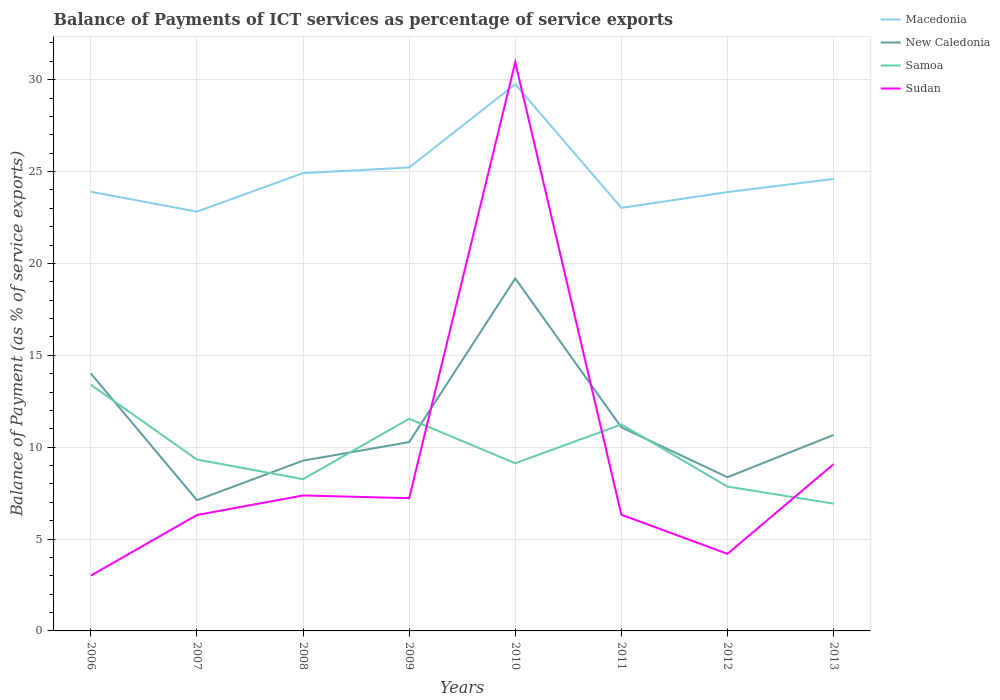How many different coloured lines are there?
Provide a succinct answer. 4. Does the line corresponding to Macedonia intersect with the line corresponding to Samoa?
Give a very brief answer. No. Is the number of lines equal to the number of legend labels?
Provide a succinct answer. Yes. Across all years, what is the maximum balance of payments of ICT services in Samoa?
Your response must be concise. 6.93. What is the total balance of payments of ICT services in Macedonia in the graph?
Your answer should be very brief. 0.62. What is the difference between the highest and the second highest balance of payments of ICT services in Sudan?
Your response must be concise. 27.94. What is the difference between the highest and the lowest balance of payments of ICT services in Macedonia?
Offer a very short reply. 3. Is the balance of payments of ICT services in Samoa strictly greater than the balance of payments of ICT services in New Caledonia over the years?
Make the answer very short. No. How many lines are there?
Provide a short and direct response. 4. How many years are there in the graph?
Offer a very short reply. 8. Where does the legend appear in the graph?
Give a very brief answer. Top right. What is the title of the graph?
Your response must be concise. Balance of Payments of ICT services as percentage of service exports. Does "Antigua and Barbuda" appear as one of the legend labels in the graph?
Offer a terse response. No. What is the label or title of the X-axis?
Ensure brevity in your answer.  Years. What is the label or title of the Y-axis?
Offer a very short reply. Balance of Payment (as % of service exports). What is the Balance of Payment (as % of service exports) of Macedonia in 2006?
Keep it short and to the point. 23.91. What is the Balance of Payment (as % of service exports) of New Caledonia in 2006?
Provide a succinct answer. 14.01. What is the Balance of Payment (as % of service exports) in Samoa in 2006?
Keep it short and to the point. 13.4. What is the Balance of Payment (as % of service exports) of Sudan in 2006?
Keep it short and to the point. 3.01. What is the Balance of Payment (as % of service exports) in Macedonia in 2007?
Provide a succinct answer. 22.82. What is the Balance of Payment (as % of service exports) in New Caledonia in 2007?
Keep it short and to the point. 7.12. What is the Balance of Payment (as % of service exports) of Samoa in 2007?
Keep it short and to the point. 9.33. What is the Balance of Payment (as % of service exports) of Sudan in 2007?
Give a very brief answer. 6.31. What is the Balance of Payment (as % of service exports) of Macedonia in 2008?
Give a very brief answer. 24.92. What is the Balance of Payment (as % of service exports) in New Caledonia in 2008?
Provide a short and direct response. 9.27. What is the Balance of Payment (as % of service exports) in Samoa in 2008?
Your answer should be very brief. 8.26. What is the Balance of Payment (as % of service exports) in Sudan in 2008?
Offer a terse response. 7.37. What is the Balance of Payment (as % of service exports) of Macedonia in 2009?
Provide a short and direct response. 25.22. What is the Balance of Payment (as % of service exports) of New Caledonia in 2009?
Your answer should be compact. 10.28. What is the Balance of Payment (as % of service exports) of Samoa in 2009?
Give a very brief answer. 11.55. What is the Balance of Payment (as % of service exports) in Sudan in 2009?
Give a very brief answer. 7.22. What is the Balance of Payment (as % of service exports) of Macedonia in 2010?
Provide a short and direct response. 29.76. What is the Balance of Payment (as % of service exports) of New Caledonia in 2010?
Provide a succinct answer. 19.18. What is the Balance of Payment (as % of service exports) in Samoa in 2010?
Ensure brevity in your answer.  9.13. What is the Balance of Payment (as % of service exports) in Sudan in 2010?
Offer a terse response. 30.95. What is the Balance of Payment (as % of service exports) in Macedonia in 2011?
Make the answer very short. 23.03. What is the Balance of Payment (as % of service exports) of New Caledonia in 2011?
Offer a very short reply. 11.08. What is the Balance of Payment (as % of service exports) in Samoa in 2011?
Offer a terse response. 11.24. What is the Balance of Payment (as % of service exports) of Sudan in 2011?
Make the answer very short. 6.32. What is the Balance of Payment (as % of service exports) of Macedonia in 2012?
Provide a short and direct response. 23.89. What is the Balance of Payment (as % of service exports) in New Caledonia in 2012?
Provide a succinct answer. 8.37. What is the Balance of Payment (as % of service exports) in Samoa in 2012?
Ensure brevity in your answer.  7.86. What is the Balance of Payment (as % of service exports) in Sudan in 2012?
Your answer should be compact. 4.2. What is the Balance of Payment (as % of service exports) in Macedonia in 2013?
Your answer should be compact. 24.6. What is the Balance of Payment (as % of service exports) of New Caledonia in 2013?
Offer a terse response. 10.66. What is the Balance of Payment (as % of service exports) of Samoa in 2013?
Make the answer very short. 6.93. What is the Balance of Payment (as % of service exports) of Sudan in 2013?
Your answer should be compact. 9.08. Across all years, what is the maximum Balance of Payment (as % of service exports) in Macedonia?
Offer a terse response. 29.76. Across all years, what is the maximum Balance of Payment (as % of service exports) in New Caledonia?
Keep it short and to the point. 19.18. Across all years, what is the maximum Balance of Payment (as % of service exports) in Samoa?
Ensure brevity in your answer.  13.4. Across all years, what is the maximum Balance of Payment (as % of service exports) of Sudan?
Offer a very short reply. 30.95. Across all years, what is the minimum Balance of Payment (as % of service exports) in Macedonia?
Provide a succinct answer. 22.82. Across all years, what is the minimum Balance of Payment (as % of service exports) of New Caledonia?
Your answer should be very brief. 7.12. Across all years, what is the minimum Balance of Payment (as % of service exports) in Samoa?
Your answer should be very brief. 6.93. Across all years, what is the minimum Balance of Payment (as % of service exports) of Sudan?
Ensure brevity in your answer.  3.01. What is the total Balance of Payment (as % of service exports) in Macedonia in the graph?
Provide a short and direct response. 198.14. What is the total Balance of Payment (as % of service exports) of New Caledonia in the graph?
Keep it short and to the point. 89.97. What is the total Balance of Payment (as % of service exports) of Samoa in the graph?
Your answer should be very brief. 77.68. What is the total Balance of Payment (as % of service exports) in Sudan in the graph?
Ensure brevity in your answer.  74.47. What is the difference between the Balance of Payment (as % of service exports) in Macedonia in 2006 and that in 2007?
Provide a short and direct response. 1.08. What is the difference between the Balance of Payment (as % of service exports) of New Caledonia in 2006 and that in 2007?
Provide a succinct answer. 6.89. What is the difference between the Balance of Payment (as % of service exports) in Samoa in 2006 and that in 2007?
Your response must be concise. 4.07. What is the difference between the Balance of Payment (as % of service exports) in Sudan in 2006 and that in 2007?
Keep it short and to the point. -3.3. What is the difference between the Balance of Payment (as % of service exports) of Macedonia in 2006 and that in 2008?
Keep it short and to the point. -1.01. What is the difference between the Balance of Payment (as % of service exports) of New Caledonia in 2006 and that in 2008?
Give a very brief answer. 4.74. What is the difference between the Balance of Payment (as % of service exports) of Samoa in 2006 and that in 2008?
Offer a terse response. 5.14. What is the difference between the Balance of Payment (as % of service exports) of Sudan in 2006 and that in 2008?
Provide a succinct answer. -4.36. What is the difference between the Balance of Payment (as % of service exports) in Macedonia in 2006 and that in 2009?
Offer a terse response. -1.32. What is the difference between the Balance of Payment (as % of service exports) in New Caledonia in 2006 and that in 2009?
Keep it short and to the point. 3.73. What is the difference between the Balance of Payment (as % of service exports) of Samoa in 2006 and that in 2009?
Your answer should be very brief. 1.85. What is the difference between the Balance of Payment (as % of service exports) in Sudan in 2006 and that in 2009?
Make the answer very short. -4.21. What is the difference between the Balance of Payment (as % of service exports) in Macedonia in 2006 and that in 2010?
Provide a short and direct response. -5.85. What is the difference between the Balance of Payment (as % of service exports) of New Caledonia in 2006 and that in 2010?
Give a very brief answer. -5.17. What is the difference between the Balance of Payment (as % of service exports) of Samoa in 2006 and that in 2010?
Offer a terse response. 4.27. What is the difference between the Balance of Payment (as % of service exports) of Sudan in 2006 and that in 2010?
Offer a terse response. -27.94. What is the difference between the Balance of Payment (as % of service exports) in Macedonia in 2006 and that in 2011?
Ensure brevity in your answer.  0.88. What is the difference between the Balance of Payment (as % of service exports) of New Caledonia in 2006 and that in 2011?
Give a very brief answer. 2.93. What is the difference between the Balance of Payment (as % of service exports) in Samoa in 2006 and that in 2011?
Keep it short and to the point. 2.16. What is the difference between the Balance of Payment (as % of service exports) of Sudan in 2006 and that in 2011?
Ensure brevity in your answer.  -3.31. What is the difference between the Balance of Payment (as % of service exports) in Macedonia in 2006 and that in 2012?
Your answer should be very brief. 0.02. What is the difference between the Balance of Payment (as % of service exports) in New Caledonia in 2006 and that in 2012?
Keep it short and to the point. 5.65. What is the difference between the Balance of Payment (as % of service exports) of Samoa in 2006 and that in 2012?
Provide a succinct answer. 5.54. What is the difference between the Balance of Payment (as % of service exports) in Sudan in 2006 and that in 2012?
Give a very brief answer. -1.19. What is the difference between the Balance of Payment (as % of service exports) of Macedonia in 2006 and that in 2013?
Your answer should be compact. -0.7. What is the difference between the Balance of Payment (as % of service exports) in New Caledonia in 2006 and that in 2013?
Keep it short and to the point. 3.35. What is the difference between the Balance of Payment (as % of service exports) of Samoa in 2006 and that in 2013?
Offer a terse response. 6.47. What is the difference between the Balance of Payment (as % of service exports) in Sudan in 2006 and that in 2013?
Your response must be concise. -6.07. What is the difference between the Balance of Payment (as % of service exports) in Macedonia in 2007 and that in 2008?
Ensure brevity in your answer.  -2.1. What is the difference between the Balance of Payment (as % of service exports) in New Caledonia in 2007 and that in 2008?
Provide a short and direct response. -2.15. What is the difference between the Balance of Payment (as % of service exports) in Samoa in 2007 and that in 2008?
Your answer should be compact. 1.07. What is the difference between the Balance of Payment (as % of service exports) of Sudan in 2007 and that in 2008?
Make the answer very short. -1.06. What is the difference between the Balance of Payment (as % of service exports) of Macedonia in 2007 and that in 2009?
Your answer should be very brief. -2.4. What is the difference between the Balance of Payment (as % of service exports) in New Caledonia in 2007 and that in 2009?
Make the answer very short. -3.16. What is the difference between the Balance of Payment (as % of service exports) in Samoa in 2007 and that in 2009?
Make the answer very short. -2.22. What is the difference between the Balance of Payment (as % of service exports) in Sudan in 2007 and that in 2009?
Ensure brevity in your answer.  -0.92. What is the difference between the Balance of Payment (as % of service exports) in Macedonia in 2007 and that in 2010?
Offer a terse response. -6.93. What is the difference between the Balance of Payment (as % of service exports) in New Caledonia in 2007 and that in 2010?
Keep it short and to the point. -12.07. What is the difference between the Balance of Payment (as % of service exports) of Samoa in 2007 and that in 2010?
Keep it short and to the point. 0.2. What is the difference between the Balance of Payment (as % of service exports) in Sudan in 2007 and that in 2010?
Ensure brevity in your answer.  -24.64. What is the difference between the Balance of Payment (as % of service exports) of Macedonia in 2007 and that in 2011?
Your response must be concise. -0.21. What is the difference between the Balance of Payment (as % of service exports) of New Caledonia in 2007 and that in 2011?
Your answer should be very brief. -3.97. What is the difference between the Balance of Payment (as % of service exports) of Samoa in 2007 and that in 2011?
Keep it short and to the point. -1.91. What is the difference between the Balance of Payment (as % of service exports) of Sudan in 2007 and that in 2011?
Offer a terse response. -0.01. What is the difference between the Balance of Payment (as % of service exports) in Macedonia in 2007 and that in 2012?
Your response must be concise. -1.06. What is the difference between the Balance of Payment (as % of service exports) of New Caledonia in 2007 and that in 2012?
Your answer should be compact. -1.25. What is the difference between the Balance of Payment (as % of service exports) in Samoa in 2007 and that in 2012?
Ensure brevity in your answer.  1.47. What is the difference between the Balance of Payment (as % of service exports) of Sudan in 2007 and that in 2012?
Offer a very short reply. 2.11. What is the difference between the Balance of Payment (as % of service exports) of Macedonia in 2007 and that in 2013?
Ensure brevity in your answer.  -1.78. What is the difference between the Balance of Payment (as % of service exports) of New Caledonia in 2007 and that in 2013?
Provide a succinct answer. -3.55. What is the difference between the Balance of Payment (as % of service exports) in Samoa in 2007 and that in 2013?
Your answer should be compact. 2.4. What is the difference between the Balance of Payment (as % of service exports) in Sudan in 2007 and that in 2013?
Make the answer very short. -2.77. What is the difference between the Balance of Payment (as % of service exports) in Macedonia in 2008 and that in 2009?
Ensure brevity in your answer.  -0.31. What is the difference between the Balance of Payment (as % of service exports) of New Caledonia in 2008 and that in 2009?
Offer a very short reply. -1.01. What is the difference between the Balance of Payment (as % of service exports) in Samoa in 2008 and that in 2009?
Ensure brevity in your answer.  -3.29. What is the difference between the Balance of Payment (as % of service exports) in Sudan in 2008 and that in 2009?
Provide a succinct answer. 0.15. What is the difference between the Balance of Payment (as % of service exports) of Macedonia in 2008 and that in 2010?
Offer a very short reply. -4.84. What is the difference between the Balance of Payment (as % of service exports) in New Caledonia in 2008 and that in 2010?
Your response must be concise. -9.92. What is the difference between the Balance of Payment (as % of service exports) of Samoa in 2008 and that in 2010?
Keep it short and to the point. -0.87. What is the difference between the Balance of Payment (as % of service exports) of Sudan in 2008 and that in 2010?
Provide a short and direct response. -23.58. What is the difference between the Balance of Payment (as % of service exports) in Macedonia in 2008 and that in 2011?
Offer a terse response. 1.89. What is the difference between the Balance of Payment (as % of service exports) of New Caledonia in 2008 and that in 2011?
Make the answer very short. -1.81. What is the difference between the Balance of Payment (as % of service exports) in Samoa in 2008 and that in 2011?
Offer a very short reply. -2.98. What is the difference between the Balance of Payment (as % of service exports) of Sudan in 2008 and that in 2011?
Offer a very short reply. 1.05. What is the difference between the Balance of Payment (as % of service exports) of Macedonia in 2008 and that in 2012?
Ensure brevity in your answer.  1.03. What is the difference between the Balance of Payment (as % of service exports) of New Caledonia in 2008 and that in 2012?
Provide a short and direct response. 0.9. What is the difference between the Balance of Payment (as % of service exports) in Samoa in 2008 and that in 2012?
Make the answer very short. 0.4. What is the difference between the Balance of Payment (as % of service exports) in Sudan in 2008 and that in 2012?
Your answer should be compact. 3.18. What is the difference between the Balance of Payment (as % of service exports) in Macedonia in 2008 and that in 2013?
Your answer should be compact. 0.32. What is the difference between the Balance of Payment (as % of service exports) in New Caledonia in 2008 and that in 2013?
Offer a terse response. -1.4. What is the difference between the Balance of Payment (as % of service exports) in Samoa in 2008 and that in 2013?
Give a very brief answer. 1.33. What is the difference between the Balance of Payment (as % of service exports) of Sudan in 2008 and that in 2013?
Provide a succinct answer. -1.71. What is the difference between the Balance of Payment (as % of service exports) in Macedonia in 2009 and that in 2010?
Provide a succinct answer. -4.53. What is the difference between the Balance of Payment (as % of service exports) in New Caledonia in 2009 and that in 2010?
Ensure brevity in your answer.  -8.91. What is the difference between the Balance of Payment (as % of service exports) in Samoa in 2009 and that in 2010?
Your answer should be compact. 2.42. What is the difference between the Balance of Payment (as % of service exports) of Sudan in 2009 and that in 2010?
Keep it short and to the point. -23.73. What is the difference between the Balance of Payment (as % of service exports) in Macedonia in 2009 and that in 2011?
Your response must be concise. 2.2. What is the difference between the Balance of Payment (as % of service exports) of New Caledonia in 2009 and that in 2011?
Keep it short and to the point. -0.8. What is the difference between the Balance of Payment (as % of service exports) in Samoa in 2009 and that in 2011?
Provide a succinct answer. 0.31. What is the difference between the Balance of Payment (as % of service exports) in Sudan in 2009 and that in 2011?
Provide a succinct answer. 0.9. What is the difference between the Balance of Payment (as % of service exports) in Macedonia in 2009 and that in 2012?
Keep it short and to the point. 1.34. What is the difference between the Balance of Payment (as % of service exports) in New Caledonia in 2009 and that in 2012?
Your answer should be compact. 1.91. What is the difference between the Balance of Payment (as % of service exports) in Samoa in 2009 and that in 2012?
Make the answer very short. 3.69. What is the difference between the Balance of Payment (as % of service exports) of Sudan in 2009 and that in 2012?
Your answer should be compact. 3.03. What is the difference between the Balance of Payment (as % of service exports) in Macedonia in 2009 and that in 2013?
Your answer should be compact. 0.62. What is the difference between the Balance of Payment (as % of service exports) of New Caledonia in 2009 and that in 2013?
Offer a very short reply. -0.39. What is the difference between the Balance of Payment (as % of service exports) in Samoa in 2009 and that in 2013?
Provide a short and direct response. 4.62. What is the difference between the Balance of Payment (as % of service exports) in Sudan in 2009 and that in 2013?
Keep it short and to the point. -1.86. What is the difference between the Balance of Payment (as % of service exports) of Macedonia in 2010 and that in 2011?
Your response must be concise. 6.73. What is the difference between the Balance of Payment (as % of service exports) of New Caledonia in 2010 and that in 2011?
Your answer should be very brief. 8.1. What is the difference between the Balance of Payment (as % of service exports) of Samoa in 2010 and that in 2011?
Keep it short and to the point. -2.11. What is the difference between the Balance of Payment (as % of service exports) in Sudan in 2010 and that in 2011?
Ensure brevity in your answer.  24.63. What is the difference between the Balance of Payment (as % of service exports) of Macedonia in 2010 and that in 2012?
Your answer should be very brief. 5.87. What is the difference between the Balance of Payment (as % of service exports) in New Caledonia in 2010 and that in 2012?
Give a very brief answer. 10.82. What is the difference between the Balance of Payment (as % of service exports) in Samoa in 2010 and that in 2012?
Keep it short and to the point. 1.27. What is the difference between the Balance of Payment (as % of service exports) in Sudan in 2010 and that in 2012?
Make the answer very short. 26.76. What is the difference between the Balance of Payment (as % of service exports) of Macedonia in 2010 and that in 2013?
Provide a succinct answer. 5.15. What is the difference between the Balance of Payment (as % of service exports) in New Caledonia in 2010 and that in 2013?
Provide a short and direct response. 8.52. What is the difference between the Balance of Payment (as % of service exports) of Samoa in 2010 and that in 2013?
Your response must be concise. 2.2. What is the difference between the Balance of Payment (as % of service exports) of Sudan in 2010 and that in 2013?
Your answer should be compact. 21.87. What is the difference between the Balance of Payment (as % of service exports) in Macedonia in 2011 and that in 2012?
Your response must be concise. -0.86. What is the difference between the Balance of Payment (as % of service exports) of New Caledonia in 2011 and that in 2012?
Offer a very short reply. 2.72. What is the difference between the Balance of Payment (as % of service exports) of Samoa in 2011 and that in 2012?
Provide a short and direct response. 3.38. What is the difference between the Balance of Payment (as % of service exports) in Sudan in 2011 and that in 2012?
Keep it short and to the point. 2.13. What is the difference between the Balance of Payment (as % of service exports) of Macedonia in 2011 and that in 2013?
Offer a terse response. -1.57. What is the difference between the Balance of Payment (as % of service exports) of New Caledonia in 2011 and that in 2013?
Provide a succinct answer. 0.42. What is the difference between the Balance of Payment (as % of service exports) of Samoa in 2011 and that in 2013?
Offer a very short reply. 4.31. What is the difference between the Balance of Payment (as % of service exports) of Sudan in 2011 and that in 2013?
Give a very brief answer. -2.76. What is the difference between the Balance of Payment (as % of service exports) of Macedonia in 2012 and that in 2013?
Make the answer very short. -0.72. What is the difference between the Balance of Payment (as % of service exports) in New Caledonia in 2012 and that in 2013?
Provide a short and direct response. -2.3. What is the difference between the Balance of Payment (as % of service exports) in Samoa in 2012 and that in 2013?
Provide a succinct answer. 0.93. What is the difference between the Balance of Payment (as % of service exports) of Sudan in 2012 and that in 2013?
Your response must be concise. -4.88. What is the difference between the Balance of Payment (as % of service exports) of Macedonia in 2006 and the Balance of Payment (as % of service exports) of New Caledonia in 2007?
Ensure brevity in your answer.  16.79. What is the difference between the Balance of Payment (as % of service exports) in Macedonia in 2006 and the Balance of Payment (as % of service exports) in Samoa in 2007?
Provide a succinct answer. 14.58. What is the difference between the Balance of Payment (as % of service exports) of Macedonia in 2006 and the Balance of Payment (as % of service exports) of Sudan in 2007?
Keep it short and to the point. 17.6. What is the difference between the Balance of Payment (as % of service exports) in New Caledonia in 2006 and the Balance of Payment (as % of service exports) in Samoa in 2007?
Your response must be concise. 4.68. What is the difference between the Balance of Payment (as % of service exports) in New Caledonia in 2006 and the Balance of Payment (as % of service exports) in Sudan in 2007?
Your answer should be compact. 7.7. What is the difference between the Balance of Payment (as % of service exports) of Samoa in 2006 and the Balance of Payment (as % of service exports) of Sudan in 2007?
Provide a succinct answer. 7.09. What is the difference between the Balance of Payment (as % of service exports) of Macedonia in 2006 and the Balance of Payment (as % of service exports) of New Caledonia in 2008?
Offer a very short reply. 14.64. What is the difference between the Balance of Payment (as % of service exports) of Macedonia in 2006 and the Balance of Payment (as % of service exports) of Samoa in 2008?
Provide a short and direct response. 15.65. What is the difference between the Balance of Payment (as % of service exports) of Macedonia in 2006 and the Balance of Payment (as % of service exports) of Sudan in 2008?
Keep it short and to the point. 16.53. What is the difference between the Balance of Payment (as % of service exports) in New Caledonia in 2006 and the Balance of Payment (as % of service exports) in Samoa in 2008?
Ensure brevity in your answer.  5.75. What is the difference between the Balance of Payment (as % of service exports) of New Caledonia in 2006 and the Balance of Payment (as % of service exports) of Sudan in 2008?
Your response must be concise. 6.64. What is the difference between the Balance of Payment (as % of service exports) in Samoa in 2006 and the Balance of Payment (as % of service exports) in Sudan in 2008?
Give a very brief answer. 6.03. What is the difference between the Balance of Payment (as % of service exports) in Macedonia in 2006 and the Balance of Payment (as % of service exports) in New Caledonia in 2009?
Provide a short and direct response. 13.63. What is the difference between the Balance of Payment (as % of service exports) of Macedonia in 2006 and the Balance of Payment (as % of service exports) of Samoa in 2009?
Provide a short and direct response. 12.36. What is the difference between the Balance of Payment (as % of service exports) in Macedonia in 2006 and the Balance of Payment (as % of service exports) in Sudan in 2009?
Your answer should be very brief. 16.68. What is the difference between the Balance of Payment (as % of service exports) of New Caledonia in 2006 and the Balance of Payment (as % of service exports) of Samoa in 2009?
Your response must be concise. 2.47. What is the difference between the Balance of Payment (as % of service exports) of New Caledonia in 2006 and the Balance of Payment (as % of service exports) of Sudan in 2009?
Your answer should be compact. 6.79. What is the difference between the Balance of Payment (as % of service exports) of Samoa in 2006 and the Balance of Payment (as % of service exports) of Sudan in 2009?
Your answer should be compact. 6.17. What is the difference between the Balance of Payment (as % of service exports) of Macedonia in 2006 and the Balance of Payment (as % of service exports) of New Caledonia in 2010?
Give a very brief answer. 4.72. What is the difference between the Balance of Payment (as % of service exports) of Macedonia in 2006 and the Balance of Payment (as % of service exports) of Samoa in 2010?
Provide a short and direct response. 14.78. What is the difference between the Balance of Payment (as % of service exports) in Macedonia in 2006 and the Balance of Payment (as % of service exports) in Sudan in 2010?
Your answer should be compact. -7.05. What is the difference between the Balance of Payment (as % of service exports) in New Caledonia in 2006 and the Balance of Payment (as % of service exports) in Samoa in 2010?
Provide a succinct answer. 4.89. What is the difference between the Balance of Payment (as % of service exports) in New Caledonia in 2006 and the Balance of Payment (as % of service exports) in Sudan in 2010?
Your answer should be compact. -16.94. What is the difference between the Balance of Payment (as % of service exports) of Samoa in 2006 and the Balance of Payment (as % of service exports) of Sudan in 2010?
Your answer should be compact. -17.55. What is the difference between the Balance of Payment (as % of service exports) of Macedonia in 2006 and the Balance of Payment (as % of service exports) of New Caledonia in 2011?
Keep it short and to the point. 12.82. What is the difference between the Balance of Payment (as % of service exports) of Macedonia in 2006 and the Balance of Payment (as % of service exports) of Samoa in 2011?
Keep it short and to the point. 12.67. What is the difference between the Balance of Payment (as % of service exports) in Macedonia in 2006 and the Balance of Payment (as % of service exports) in Sudan in 2011?
Provide a short and direct response. 17.58. What is the difference between the Balance of Payment (as % of service exports) in New Caledonia in 2006 and the Balance of Payment (as % of service exports) in Samoa in 2011?
Keep it short and to the point. 2.77. What is the difference between the Balance of Payment (as % of service exports) in New Caledonia in 2006 and the Balance of Payment (as % of service exports) in Sudan in 2011?
Ensure brevity in your answer.  7.69. What is the difference between the Balance of Payment (as % of service exports) in Samoa in 2006 and the Balance of Payment (as % of service exports) in Sudan in 2011?
Give a very brief answer. 7.07. What is the difference between the Balance of Payment (as % of service exports) in Macedonia in 2006 and the Balance of Payment (as % of service exports) in New Caledonia in 2012?
Keep it short and to the point. 15.54. What is the difference between the Balance of Payment (as % of service exports) in Macedonia in 2006 and the Balance of Payment (as % of service exports) in Samoa in 2012?
Provide a short and direct response. 16.05. What is the difference between the Balance of Payment (as % of service exports) of Macedonia in 2006 and the Balance of Payment (as % of service exports) of Sudan in 2012?
Ensure brevity in your answer.  19.71. What is the difference between the Balance of Payment (as % of service exports) in New Caledonia in 2006 and the Balance of Payment (as % of service exports) in Samoa in 2012?
Your answer should be very brief. 6.16. What is the difference between the Balance of Payment (as % of service exports) of New Caledonia in 2006 and the Balance of Payment (as % of service exports) of Sudan in 2012?
Give a very brief answer. 9.82. What is the difference between the Balance of Payment (as % of service exports) of Samoa in 2006 and the Balance of Payment (as % of service exports) of Sudan in 2012?
Make the answer very short. 9.2. What is the difference between the Balance of Payment (as % of service exports) in Macedonia in 2006 and the Balance of Payment (as % of service exports) in New Caledonia in 2013?
Your answer should be compact. 13.24. What is the difference between the Balance of Payment (as % of service exports) of Macedonia in 2006 and the Balance of Payment (as % of service exports) of Samoa in 2013?
Your answer should be compact. 16.98. What is the difference between the Balance of Payment (as % of service exports) in Macedonia in 2006 and the Balance of Payment (as % of service exports) in Sudan in 2013?
Ensure brevity in your answer.  14.83. What is the difference between the Balance of Payment (as % of service exports) in New Caledonia in 2006 and the Balance of Payment (as % of service exports) in Samoa in 2013?
Provide a short and direct response. 7.08. What is the difference between the Balance of Payment (as % of service exports) of New Caledonia in 2006 and the Balance of Payment (as % of service exports) of Sudan in 2013?
Offer a very short reply. 4.93. What is the difference between the Balance of Payment (as % of service exports) of Samoa in 2006 and the Balance of Payment (as % of service exports) of Sudan in 2013?
Offer a very short reply. 4.32. What is the difference between the Balance of Payment (as % of service exports) of Macedonia in 2007 and the Balance of Payment (as % of service exports) of New Caledonia in 2008?
Offer a very short reply. 13.55. What is the difference between the Balance of Payment (as % of service exports) in Macedonia in 2007 and the Balance of Payment (as % of service exports) in Samoa in 2008?
Keep it short and to the point. 14.56. What is the difference between the Balance of Payment (as % of service exports) in Macedonia in 2007 and the Balance of Payment (as % of service exports) in Sudan in 2008?
Ensure brevity in your answer.  15.45. What is the difference between the Balance of Payment (as % of service exports) of New Caledonia in 2007 and the Balance of Payment (as % of service exports) of Samoa in 2008?
Your answer should be compact. -1.14. What is the difference between the Balance of Payment (as % of service exports) of New Caledonia in 2007 and the Balance of Payment (as % of service exports) of Sudan in 2008?
Provide a succinct answer. -0.26. What is the difference between the Balance of Payment (as % of service exports) in Samoa in 2007 and the Balance of Payment (as % of service exports) in Sudan in 2008?
Give a very brief answer. 1.95. What is the difference between the Balance of Payment (as % of service exports) of Macedonia in 2007 and the Balance of Payment (as % of service exports) of New Caledonia in 2009?
Give a very brief answer. 12.54. What is the difference between the Balance of Payment (as % of service exports) in Macedonia in 2007 and the Balance of Payment (as % of service exports) in Samoa in 2009?
Your answer should be very brief. 11.27. What is the difference between the Balance of Payment (as % of service exports) in Macedonia in 2007 and the Balance of Payment (as % of service exports) in Sudan in 2009?
Your answer should be very brief. 15.6. What is the difference between the Balance of Payment (as % of service exports) of New Caledonia in 2007 and the Balance of Payment (as % of service exports) of Samoa in 2009?
Offer a very short reply. -4.43. What is the difference between the Balance of Payment (as % of service exports) in New Caledonia in 2007 and the Balance of Payment (as % of service exports) in Sudan in 2009?
Ensure brevity in your answer.  -0.11. What is the difference between the Balance of Payment (as % of service exports) in Samoa in 2007 and the Balance of Payment (as % of service exports) in Sudan in 2009?
Provide a short and direct response. 2.1. What is the difference between the Balance of Payment (as % of service exports) in Macedonia in 2007 and the Balance of Payment (as % of service exports) in New Caledonia in 2010?
Provide a succinct answer. 3.64. What is the difference between the Balance of Payment (as % of service exports) in Macedonia in 2007 and the Balance of Payment (as % of service exports) in Samoa in 2010?
Keep it short and to the point. 13.7. What is the difference between the Balance of Payment (as % of service exports) in Macedonia in 2007 and the Balance of Payment (as % of service exports) in Sudan in 2010?
Your answer should be very brief. -8.13. What is the difference between the Balance of Payment (as % of service exports) of New Caledonia in 2007 and the Balance of Payment (as % of service exports) of Samoa in 2010?
Your answer should be very brief. -2.01. What is the difference between the Balance of Payment (as % of service exports) of New Caledonia in 2007 and the Balance of Payment (as % of service exports) of Sudan in 2010?
Provide a short and direct response. -23.84. What is the difference between the Balance of Payment (as % of service exports) in Samoa in 2007 and the Balance of Payment (as % of service exports) in Sudan in 2010?
Provide a succinct answer. -21.62. What is the difference between the Balance of Payment (as % of service exports) in Macedonia in 2007 and the Balance of Payment (as % of service exports) in New Caledonia in 2011?
Give a very brief answer. 11.74. What is the difference between the Balance of Payment (as % of service exports) of Macedonia in 2007 and the Balance of Payment (as % of service exports) of Samoa in 2011?
Your answer should be very brief. 11.58. What is the difference between the Balance of Payment (as % of service exports) of Macedonia in 2007 and the Balance of Payment (as % of service exports) of Sudan in 2011?
Your response must be concise. 16.5. What is the difference between the Balance of Payment (as % of service exports) in New Caledonia in 2007 and the Balance of Payment (as % of service exports) in Samoa in 2011?
Give a very brief answer. -4.12. What is the difference between the Balance of Payment (as % of service exports) of New Caledonia in 2007 and the Balance of Payment (as % of service exports) of Sudan in 2011?
Keep it short and to the point. 0.79. What is the difference between the Balance of Payment (as % of service exports) in Samoa in 2007 and the Balance of Payment (as % of service exports) in Sudan in 2011?
Provide a short and direct response. 3. What is the difference between the Balance of Payment (as % of service exports) of Macedonia in 2007 and the Balance of Payment (as % of service exports) of New Caledonia in 2012?
Your answer should be compact. 14.45. What is the difference between the Balance of Payment (as % of service exports) in Macedonia in 2007 and the Balance of Payment (as % of service exports) in Samoa in 2012?
Ensure brevity in your answer.  14.97. What is the difference between the Balance of Payment (as % of service exports) in Macedonia in 2007 and the Balance of Payment (as % of service exports) in Sudan in 2012?
Give a very brief answer. 18.63. What is the difference between the Balance of Payment (as % of service exports) in New Caledonia in 2007 and the Balance of Payment (as % of service exports) in Samoa in 2012?
Offer a very short reply. -0.74. What is the difference between the Balance of Payment (as % of service exports) of New Caledonia in 2007 and the Balance of Payment (as % of service exports) of Sudan in 2012?
Keep it short and to the point. 2.92. What is the difference between the Balance of Payment (as % of service exports) in Samoa in 2007 and the Balance of Payment (as % of service exports) in Sudan in 2012?
Offer a very short reply. 5.13. What is the difference between the Balance of Payment (as % of service exports) in Macedonia in 2007 and the Balance of Payment (as % of service exports) in New Caledonia in 2013?
Your answer should be very brief. 12.16. What is the difference between the Balance of Payment (as % of service exports) of Macedonia in 2007 and the Balance of Payment (as % of service exports) of Samoa in 2013?
Your answer should be very brief. 15.89. What is the difference between the Balance of Payment (as % of service exports) of Macedonia in 2007 and the Balance of Payment (as % of service exports) of Sudan in 2013?
Make the answer very short. 13.74. What is the difference between the Balance of Payment (as % of service exports) in New Caledonia in 2007 and the Balance of Payment (as % of service exports) in Samoa in 2013?
Make the answer very short. 0.19. What is the difference between the Balance of Payment (as % of service exports) of New Caledonia in 2007 and the Balance of Payment (as % of service exports) of Sudan in 2013?
Offer a very short reply. -1.96. What is the difference between the Balance of Payment (as % of service exports) of Samoa in 2007 and the Balance of Payment (as % of service exports) of Sudan in 2013?
Make the answer very short. 0.25. What is the difference between the Balance of Payment (as % of service exports) of Macedonia in 2008 and the Balance of Payment (as % of service exports) of New Caledonia in 2009?
Give a very brief answer. 14.64. What is the difference between the Balance of Payment (as % of service exports) of Macedonia in 2008 and the Balance of Payment (as % of service exports) of Samoa in 2009?
Offer a terse response. 13.37. What is the difference between the Balance of Payment (as % of service exports) in Macedonia in 2008 and the Balance of Payment (as % of service exports) in Sudan in 2009?
Your answer should be compact. 17.69. What is the difference between the Balance of Payment (as % of service exports) of New Caledonia in 2008 and the Balance of Payment (as % of service exports) of Samoa in 2009?
Provide a short and direct response. -2.28. What is the difference between the Balance of Payment (as % of service exports) of New Caledonia in 2008 and the Balance of Payment (as % of service exports) of Sudan in 2009?
Your response must be concise. 2.04. What is the difference between the Balance of Payment (as % of service exports) of Samoa in 2008 and the Balance of Payment (as % of service exports) of Sudan in 2009?
Offer a very short reply. 1.03. What is the difference between the Balance of Payment (as % of service exports) in Macedonia in 2008 and the Balance of Payment (as % of service exports) in New Caledonia in 2010?
Provide a succinct answer. 5.73. What is the difference between the Balance of Payment (as % of service exports) of Macedonia in 2008 and the Balance of Payment (as % of service exports) of Samoa in 2010?
Make the answer very short. 15.79. What is the difference between the Balance of Payment (as % of service exports) of Macedonia in 2008 and the Balance of Payment (as % of service exports) of Sudan in 2010?
Keep it short and to the point. -6.03. What is the difference between the Balance of Payment (as % of service exports) of New Caledonia in 2008 and the Balance of Payment (as % of service exports) of Samoa in 2010?
Your response must be concise. 0.14. What is the difference between the Balance of Payment (as % of service exports) in New Caledonia in 2008 and the Balance of Payment (as % of service exports) in Sudan in 2010?
Make the answer very short. -21.68. What is the difference between the Balance of Payment (as % of service exports) of Samoa in 2008 and the Balance of Payment (as % of service exports) of Sudan in 2010?
Your answer should be very brief. -22.69. What is the difference between the Balance of Payment (as % of service exports) in Macedonia in 2008 and the Balance of Payment (as % of service exports) in New Caledonia in 2011?
Offer a terse response. 13.84. What is the difference between the Balance of Payment (as % of service exports) of Macedonia in 2008 and the Balance of Payment (as % of service exports) of Samoa in 2011?
Your answer should be compact. 13.68. What is the difference between the Balance of Payment (as % of service exports) of Macedonia in 2008 and the Balance of Payment (as % of service exports) of Sudan in 2011?
Provide a succinct answer. 18.59. What is the difference between the Balance of Payment (as % of service exports) in New Caledonia in 2008 and the Balance of Payment (as % of service exports) in Samoa in 2011?
Offer a very short reply. -1.97. What is the difference between the Balance of Payment (as % of service exports) of New Caledonia in 2008 and the Balance of Payment (as % of service exports) of Sudan in 2011?
Your response must be concise. 2.94. What is the difference between the Balance of Payment (as % of service exports) of Samoa in 2008 and the Balance of Payment (as % of service exports) of Sudan in 2011?
Your answer should be compact. 1.94. What is the difference between the Balance of Payment (as % of service exports) of Macedonia in 2008 and the Balance of Payment (as % of service exports) of New Caledonia in 2012?
Ensure brevity in your answer.  16.55. What is the difference between the Balance of Payment (as % of service exports) in Macedonia in 2008 and the Balance of Payment (as % of service exports) in Samoa in 2012?
Keep it short and to the point. 17.06. What is the difference between the Balance of Payment (as % of service exports) in Macedonia in 2008 and the Balance of Payment (as % of service exports) in Sudan in 2012?
Keep it short and to the point. 20.72. What is the difference between the Balance of Payment (as % of service exports) of New Caledonia in 2008 and the Balance of Payment (as % of service exports) of Samoa in 2012?
Offer a terse response. 1.41. What is the difference between the Balance of Payment (as % of service exports) in New Caledonia in 2008 and the Balance of Payment (as % of service exports) in Sudan in 2012?
Give a very brief answer. 5.07. What is the difference between the Balance of Payment (as % of service exports) of Samoa in 2008 and the Balance of Payment (as % of service exports) of Sudan in 2012?
Give a very brief answer. 4.06. What is the difference between the Balance of Payment (as % of service exports) of Macedonia in 2008 and the Balance of Payment (as % of service exports) of New Caledonia in 2013?
Your answer should be compact. 14.25. What is the difference between the Balance of Payment (as % of service exports) of Macedonia in 2008 and the Balance of Payment (as % of service exports) of Samoa in 2013?
Offer a very short reply. 17.99. What is the difference between the Balance of Payment (as % of service exports) in Macedonia in 2008 and the Balance of Payment (as % of service exports) in Sudan in 2013?
Give a very brief answer. 15.84. What is the difference between the Balance of Payment (as % of service exports) of New Caledonia in 2008 and the Balance of Payment (as % of service exports) of Samoa in 2013?
Make the answer very short. 2.34. What is the difference between the Balance of Payment (as % of service exports) in New Caledonia in 2008 and the Balance of Payment (as % of service exports) in Sudan in 2013?
Offer a very short reply. 0.19. What is the difference between the Balance of Payment (as % of service exports) in Samoa in 2008 and the Balance of Payment (as % of service exports) in Sudan in 2013?
Your answer should be very brief. -0.82. What is the difference between the Balance of Payment (as % of service exports) of Macedonia in 2009 and the Balance of Payment (as % of service exports) of New Caledonia in 2010?
Your response must be concise. 6.04. What is the difference between the Balance of Payment (as % of service exports) of Macedonia in 2009 and the Balance of Payment (as % of service exports) of Samoa in 2010?
Offer a very short reply. 16.1. What is the difference between the Balance of Payment (as % of service exports) of Macedonia in 2009 and the Balance of Payment (as % of service exports) of Sudan in 2010?
Ensure brevity in your answer.  -5.73. What is the difference between the Balance of Payment (as % of service exports) of New Caledonia in 2009 and the Balance of Payment (as % of service exports) of Samoa in 2010?
Your answer should be compact. 1.15. What is the difference between the Balance of Payment (as % of service exports) in New Caledonia in 2009 and the Balance of Payment (as % of service exports) in Sudan in 2010?
Ensure brevity in your answer.  -20.67. What is the difference between the Balance of Payment (as % of service exports) in Samoa in 2009 and the Balance of Payment (as % of service exports) in Sudan in 2010?
Provide a short and direct response. -19.41. What is the difference between the Balance of Payment (as % of service exports) of Macedonia in 2009 and the Balance of Payment (as % of service exports) of New Caledonia in 2011?
Ensure brevity in your answer.  14.14. What is the difference between the Balance of Payment (as % of service exports) in Macedonia in 2009 and the Balance of Payment (as % of service exports) in Samoa in 2011?
Keep it short and to the point. 13.99. What is the difference between the Balance of Payment (as % of service exports) of Macedonia in 2009 and the Balance of Payment (as % of service exports) of Sudan in 2011?
Offer a very short reply. 18.9. What is the difference between the Balance of Payment (as % of service exports) in New Caledonia in 2009 and the Balance of Payment (as % of service exports) in Samoa in 2011?
Provide a succinct answer. -0.96. What is the difference between the Balance of Payment (as % of service exports) of New Caledonia in 2009 and the Balance of Payment (as % of service exports) of Sudan in 2011?
Your answer should be very brief. 3.95. What is the difference between the Balance of Payment (as % of service exports) of Samoa in 2009 and the Balance of Payment (as % of service exports) of Sudan in 2011?
Make the answer very short. 5.22. What is the difference between the Balance of Payment (as % of service exports) of Macedonia in 2009 and the Balance of Payment (as % of service exports) of New Caledonia in 2012?
Offer a terse response. 16.86. What is the difference between the Balance of Payment (as % of service exports) in Macedonia in 2009 and the Balance of Payment (as % of service exports) in Samoa in 2012?
Make the answer very short. 17.37. What is the difference between the Balance of Payment (as % of service exports) in Macedonia in 2009 and the Balance of Payment (as % of service exports) in Sudan in 2012?
Your answer should be very brief. 21.03. What is the difference between the Balance of Payment (as % of service exports) in New Caledonia in 2009 and the Balance of Payment (as % of service exports) in Samoa in 2012?
Give a very brief answer. 2.42. What is the difference between the Balance of Payment (as % of service exports) of New Caledonia in 2009 and the Balance of Payment (as % of service exports) of Sudan in 2012?
Keep it short and to the point. 6.08. What is the difference between the Balance of Payment (as % of service exports) in Samoa in 2009 and the Balance of Payment (as % of service exports) in Sudan in 2012?
Provide a short and direct response. 7.35. What is the difference between the Balance of Payment (as % of service exports) in Macedonia in 2009 and the Balance of Payment (as % of service exports) in New Caledonia in 2013?
Provide a short and direct response. 14.56. What is the difference between the Balance of Payment (as % of service exports) in Macedonia in 2009 and the Balance of Payment (as % of service exports) in Samoa in 2013?
Ensure brevity in your answer.  18.3. What is the difference between the Balance of Payment (as % of service exports) in Macedonia in 2009 and the Balance of Payment (as % of service exports) in Sudan in 2013?
Offer a very short reply. 16.14. What is the difference between the Balance of Payment (as % of service exports) of New Caledonia in 2009 and the Balance of Payment (as % of service exports) of Samoa in 2013?
Make the answer very short. 3.35. What is the difference between the Balance of Payment (as % of service exports) of New Caledonia in 2009 and the Balance of Payment (as % of service exports) of Sudan in 2013?
Make the answer very short. 1.2. What is the difference between the Balance of Payment (as % of service exports) in Samoa in 2009 and the Balance of Payment (as % of service exports) in Sudan in 2013?
Your response must be concise. 2.47. What is the difference between the Balance of Payment (as % of service exports) of Macedonia in 2010 and the Balance of Payment (as % of service exports) of New Caledonia in 2011?
Your answer should be very brief. 18.67. What is the difference between the Balance of Payment (as % of service exports) in Macedonia in 2010 and the Balance of Payment (as % of service exports) in Samoa in 2011?
Ensure brevity in your answer.  18.52. What is the difference between the Balance of Payment (as % of service exports) in Macedonia in 2010 and the Balance of Payment (as % of service exports) in Sudan in 2011?
Ensure brevity in your answer.  23.43. What is the difference between the Balance of Payment (as % of service exports) of New Caledonia in 2010 and the Balance of Payment (as % of service exports) of Samoa in 2011?
Your answer should be very brief. 7.95. What is the difference between the Balance of Payment (as % of service exports) of New Caledonia in 2010 and the Balance of Payment (as % of service exports) of Sudan in 2011?
Ensure brevity in your answer.  12.86. What is the difference between the Balance of Payment (as % of service exports) in Samoa in 2010 and the Balance of Payment (as % of service exports) in Sudan in 2011?
Provide a succinct answer. 2.8. What is the difference between the Balance of Payment (as % of service exports) of Macedonia in 2010 and the Balance of Payment (as % of service exports) of New Caledonia in 2012?
Keep it short and to the point. 21.39. What is the difference between the Balance of Payment (as % of service exports) in Macedonia in 2010 and the Balance of Payment (as % of service exports) in Samoa in 2012?
Provide a short and direct response. 21.9. What is the difference between the Balance of Payment (as % of service exports) of Macedonia in 2010 and the Balance of Payment (as % of service exports) of Sudan in 2012?
Your response must be concise. 25.56. What is the difference between the Balance of Payment (as % of service exports) in New Caledonia in 2010 and the Balance of Payment (as % of service exports) in Samoa in 2012?
Provide a succinct answer. 11.33. What is the difference between the Balance of Payment (as % of service exports) of New Caledonia in 2010 and the Balance of Payment (as % of service exports) of Sudan in 2012?
Provide a succinct answer. 14.99. What is the difference between the Balance of Payment (as % of service exports) of Samoa in 2010 and the Balance of Payment (as % of service exports) of Sudan in 2012?
Your answer should be compact. 4.93. What is the difference between the Balance of Payment (as % of service exports) in Macedonia in 2010 and the Balance of Payment (as % of service exports) in New Caledonia in 2013?
Ensure brevity in your answer.  19.09. What is the difference between the Balance of Payment (as % of service exports) of Macedonia in 2010 and the Balance of Payment (as % of service exports) of Samoa in 2013?
Offer a terse response. 22.83. What is the difference between the Balance of Payment (as % of service exports) in Macedonia in 2010 and the Balance of Payment (as % of service exports) in Sudan in 2013?
Offer a very short reply. 20.68. What is the difference between the Balance of Payment (as % of service exports) in New Caledonia in 2010 and the Balance of Payment (as % of service exports) in Samoa in 2013?
Keep it short and to the point. 12.26. What is the difference between the Balance of Payment (as % of service exports) in New Caledonia in 2010 and the Balance of Payment (as % of service exports) in Sudan in 2013?
Your answer should be very brief. 10.1. What is the difference between the Balance of Payment (as % of service exports) in Samoa in 2010 and the Balance of Payment (as % of service exports) in Sudan in 2013?
Your answer should be very brief. 0.05. What is the difference between the Balance of Payment (as % of service exports) of Macedonia in 2011 and the Balance of Payment (as % of service exports) of New Caledonia in 2012?
Offer a very short reply. 14.66. What is the difference between the Balance of Payment (as % of service exports) of Macedonia in 2011 and the Balance of Payment (as % of service exports) of Samoa in 2012?
Provide a succinct answer. 15.17. What is the difference between the Balance of Payment (as % of service exports) of Macedonia in 2011 and the Balance of Payment (as % of service exports) of Sudan in 2012?
Ensure brevity in your answer.  18.83. What is the difference between the Balance of Payment (as % of service exports) in New Caledonia in 2011 and the Balance of Payment (as % of service exports) in Samoa in 2012?
Provide a succinct answer. 3.23. What is the difference between the Balance of Payment (as % of service exports) of New Caledonia in 2011 and the Balance of Payment (as % of service exports) of Sudan in 2012?
Your answer should be compact. 6.89. What is the difference between the Balance of Payment (as % of service exports) in Samoa in 2011 and the Balance of Payment (as % of service exports) in Sudan in 2012?
Offer a very short reply. 7.04. What is the difference between the Balance of Payment (as % of service exports) of Macedonia in 2011 and the Balance of Payment (as % of service exports) of New Caledonia in 2013?
Provide a succinct answer. 12.36. What is the difference between the Balance of Payment (as % of service exports) in Macedonia in 2011 and the Balance of Payment (as % of service exports) in Samoa in 2013?
Offer a very short reply. 16.1. What is the difference between the Balance of Payment (as % of service exports) of Macedonia in 2011 and the Balance of Payment (as % of service exports) of Sudan in 2013?
Offer a very short reply. 13.95. What is the difference between the Balance of Payment (as % of service exports) of New Caledonia in 2011 and the Balance of Payment (as % of service exports) of Samoa in 2013?
Make the answer very short. 4.15. What is the difference between the Balance of Payment (as % of service exports) in New Caledonia in 2011 and the Balance of Payment (as % of service exports) in Sudan in 2013?
Offer a terse response. 2. What is the difference between the Balance of Payment (as % of service exports) in Samoa in 2011 and the Balance of Payment (as % of service exports) in Sudan in 2013?
Your response must be concise. 2.16. What is the difference between the Balance of Payment (as % of service exports) in Macedonia in 2012 and the Balance of Payment (as % of service exports) in New Caledonia in 2013?
Your answer should be very brief. 13.22. What is the difference between the Balance of Payment (as % of service exports) of Macedonia in 2012 and the Balance of Payment (as % of service exports) of Samoa in 2013?
Offer a terse response. 16.96. What is the difference between the Balance of Payment (as % of service exports) in Macedonia in 2012 and the Balance of Payment (as % of service exports) in Sudan in 2013?
Keep it short and to the point. 14.81. What is the difference between the Balance of Payment (as % of service exports) of New Caledonia in 2012 and the Balance of Payment (as % of service exports) of Samoa in 2013?
Your answer should be very brief. 1.44. What is the difference between the Balance of Payment (as % of service exports) in New Caledonia in 2012 and the Balance of Payment (as % of service exports) in Sudan in 2013?
Your response must be concise. -0.71. What is the difference between the Balance of Payment (as % of service exports) in Samoa in 2012 and the Balance of Payment (as % of service exports) in Sudan in 2013?
Provide a succinct answer. -1.22. What is the average Balance of Payment (as % of service exports) in Macedonia per year?
Ensure brevity in your answer.  24.77. What is the average Balance of Payment (as % of service exports) of New Caledonia per year?
Offer a very short reply. 11.25. What is the average Balance of Payment (as % of service exports) in Samoa per year?
Keep it short and to the point. 9.71. What is the average Balance of Payment (as % of service exports) of Sudan per year?
Ensure brevity in your answer.  9.31. In the year 2006, what is the difference between the Balance of Payment (as % of service exports) of Macedonia and Balance of Payment (as % of service exports) of New Caledonia?
Your response must be concise. 9.89. In the year 2006, what is the difference between the Balance of Payment (as % of service exports) in Macedonia and Balance of Payment (as % of service exports) in Samoa?
Keep it short and to the point. 10.51. In the year 2006, what is the difference between the Balance of Payment (as % of service exports) in Macedonia and Balance of Payment (as % of service exports) in Sudan?
Your response must be concise. 20.9. In the year 2006, what is the difference between the Balance of Payment (as % of service exports) in New Caledonia and Balance of Payment (as % of service exports) in Samoa?
Ensure brevity in your answer.  0.61. In the year 2006, what is the difference between the Balance of Payment (as % of service exports) in New Caledonia and Balance of Payment (as % of service exports) in Sudan?
Your answer should be compact. 11. In the year 2006, what is the difference between the Balance of Payment (as % of service exports) in Samoa and Balance of Payment (as % of service exports) in Sudan?
Your response must be concise. 10.39. In the year 2007, what is the difference between the Balance of Payment (as % of service exports) of Macedonia and Balance of Payment (as % of service exports) of New Caledonia?
Offer a terse response. 15.7. In the year 2007, what is the difference between the Balance of Payment (as % of service exports) in Macedonia and Balance of Payment (as % of service exports) in Samoa?
Offer a very short reply. 13.49. In the year 2007, what is the difference between the Balance of Payment (as % of service exports) of Macedonia and Balance of Payment (as % of service exports) of Sudan?
Give a very brief answer. 16.51. In the year 2007, what is the difference between the Balance of Payment (as % of service exports) in New Caledonia and Balance of Payment (as % of service exports) in Samoa?
Provide a short and direct response. -2.21. In the year 2007, what is the difference between the Balance of Payment (as % of service exports) in New Caledonia and Balance of Payment (as % of service exports) in Sudan?
Your response must be concise. 0.81. In the year 2007, what is the difference between the Balance of Payment (as % of service exports) of Samoa and Balance of Payment (as % of service exports) of Sudan?
Make the answer very short. 3.02. In the year 2008, what is the difference between the Balance of Payment (as % of service exports) of Macedonia and Balance of Payment (as % of service exports) of New Caledonia?
Give a very brief answer. 15.65. In the year 2008, what is the difference between the Balance of Payment (as % of service exports) of Macedonia and Balance of Payment (as % of service exports) of Samoa?
Your response must be concise. 16.66. In the year 2008, what is the difference between the Balance of Payment (as % of service exports) of Macedonia and Balance of Payment (as % of service exports) of Sudan?
Make the answer very short. 17.55. In the year 2008, what is the difference between the Balance of Payment (as % of service exports) of New Caledonia and Balance of Payment (as % of service exports) of Samoa?
Your response must be concise. 1.01. In the year 2008, what is the difference between the Balance of Payment (as % of service exports) in New Caledonia and Balance of Payment (as % of service exports) in Sudan?
Offer a very short reply. 1.89. In the year 2008, what is the difference between the Balance of Payment (as % of service exports) of Samoa and Balance of Payment (as % of service exports) of Sudan?
Keep it short and to the point. 0.89. In the year 2009, what is the difference between the Balance of Payment (as % of service exports) in Macedonia and Balance of Payment (as % of service exports) in New Caledonia?
Provide a succinct answer. 14.95. In the year 2009, what is the difference between the Balance of Payment (as % of service exports) in Macedonia and Balance of Payment (as % of service exports) in Samoa?
Your response must be concise. 13.68. In the year 2009, what is the difference between the Balance of Payment (as % of service exports) of Macedonia and Balance of Payment (as % of service exports) of Sudan?
Provide a short and direct response. 18. In the year 2009, what is the difference between the Balance of Payment (as % of service exports) in New Caledonia and Balance of Payment (as % of service exports) in Samoa?
Ensure brevity in your answer.  -1.27. In the year 2009, what is the difference between the Balance of Payment (as % of service exports) in New Caledonia and Balance of Payment (as % of service exports) in Sudan?
Provide a short and direct response. 3.05. In the year 2009, what is the difference between the Balance of Payment (as % of service exports) of Samoa and Balance of Payment (as % of service exports) of Sudan?
Provide a short and direct response. 4.32. In the year 2010, what is the difference between the Balance of Payment (as % of service exports) of Macedonia and Balance of Payment (as % of service exports) of New Caledonia?
Your answer should be very brief. 10.57. In the year 2010, what is the difference between the Balance of Payment (as % of service exports) of Macedonia and Balance of Payment (as % of service exports) of Samoa?
Offer a terse response. 20.63. In the year 2010, what is the difference between the Balance of Payment (as % of service exports) in Macedonia and Balance of Payment (as % of service exports) in Sudan?
Your response must be concise. -1.2. In the year 2010, what is the difference between the Balance of Payment (as % of service exports) in New Caledonia and Balance of Payment (as % of service exports) in Samoa?
Ensure brevity in your answer.  10.06. In the year 2010, what is the difference between the Balance of Payment (as % of service exports) of New Caledonia and Balance of Payment (as % of service exports) of Sudan?
Your response must be concise. -11.77. In the year 2010, what is the difference between the Balance of Payment (as % of service exports) of Samoa and Balance of Payment (as % of service exports) of Sudan?
Ensure brevity in your answer.  -21.83. In the year 2011, what is the difference between the Balance of Payment (as % of service exports) of Macedonia and Balance of Payment (as % of service exports) of New Caledonia?
Ensure brevity in your answer.  11.94. In the year 2011, what is the difference between the Balance of Payment (as % of service exports) in Macedonia and Balance of Payment (as % of service exports) in Samoa?
Give a very brief answer. 11.79. In the year 2011, what is the difference between the Balance of Payment (as % of service exports) of Macedonia and Balance of Payment (as % of service exports) of Sudan?
Your response must be concise. 16.7. In the year 2011, what is the difference between the Balance of Payment (as % of service exports) in New Caledonia and Balance of Payment (as % of service exports) in Samoa?
Provide a succinct answer. -0.16. In the year 2011, what is the difference between the Balance of Payment (as % of service exports) of New Caledonia and Balance of Payment (as % of service exports) of Sudan?
Ensure brevity in your answer.  4.76. In the year 2011, what is the difference between the Balance of Payment (as % of service exports) in Samoa and Balance of Payment (as % of service exports) in Sudan?
Your answer should be very brief. 4.92. In the year 2012, what is the difference between the Balance of Payment (as % of service exports) of Macedonia and Balance of Payment (as % of service exports) of New Caledonia?
Offer a very short reply. 15.52. In the year 2012, what is the difference between the Balance of Payment (as % of service exports) in Macedonia and Balance of Payment (as % of service exports) in Samoa?
Offer a terse response. 16.03. In the year 2012, what is the difference between the Balance of Payment (as % of service exports) in Macedonia and Balance of Payment (as % of service exports) in Sudan?
Make the answer very short. 19.69. In the year 2012, what is the difference between the Balance of Payment (as % of service exports) in New Caledonia and Balance of Payment (as % of service exports) in Samoa?
Give a very brief answer. 0.51. In the year 2012, what is the difference between the Balance of Payment (as % of service exports) of New Caledonia and Balance of Payment (as % of service exports) of Sudan?
Make the answer very short. 4.17. In the year 2012, what is the difference between the Balance of Payment (as % of service exports) in Samoa and Balance of Payment (as % of service exports) in Sudan?
Offer a very short reply. 3.66. In the year 2013, what is the difference between the Balance of Payment (as % of service exports) of Macedonia and Balance of Payment (as % of service exports) of New Caledonia?
Offer a very short reply. 13.94. In the year 2013, what is the difference between the Balance of Payment (as % of service exports) of Macedonia and Balance of Payment (as % of service exports) of Samoa?
Ensure brevity in your answer.  17.67. In the year 2013, what is the difference between the Balance of Payment (as % of service exports) in Macedonia and Balance of Payment (as % of service exports) in Sudan?
Your answer should be compact. 15.52. In the year 2013, what is the difference between the Balance of Payment (as % of service exports) in New Caledonia and Balance of Payment (as % of service exports) in Samoa?
Your answer should be compact. 3.74. In the year 2013, what is the difference between the Balance of Payment (as % of service exports) in New Caledonia and Balance of Payment (as % of service exports) in Sudan?
Offer a very short reply. 1.58. In the year 2013, what is the difference between the Balance of Payment (as % of service exports) of Samoa and Balance of Payment (as % of service exports) of Sudan?
Keep it short and to the point. -2.15. What is the ratio of the Balance of Payment (as % of service exports) in Macedonia in 2006 to that in 2007?
Offer a very short reply. 1.05. What is the ratio of the Balance of Payment (as % of service exports) of New Caledonia in 2006 to that in 2007?
Offer a terse response. 1.97. What is the ratio of the Balance of Payment (as % of service exports) of Samoa in 2006 to that in 2007?
Your response must be concise. 1.44. What is the ratio of the Balance of Payment (as % of service exports) in Sudan in 2006 to that in 2007?
Offer a very short reply. 0.48. What is the ratio of the Balance of Payment (as % of service exports) in Macedonia in 2006 to that in 2008?
Your answer should be very brief. 0.96. What is the ratio of the Balance of Payment (as % of service exports) in New Caledonia in 2006 to that in 2008?
Make the answer very short. 1.51. What is the ratio of the Balance of Payment (as % of service exports) in Samoa in 2006 to that in 2008?
Your answer should be compact. 1.62. What is the ratio of the Balance of Payment (as % of service exports) in Sudan in 2006 to that in 2008?
Make the answer very short. 0.41. What is the ratio of the Balance of Payment (as % of service exports) of Macedonia in 2006 to that in 2009?
Provide a succinct answer. 0.95. What is the ratio of the Balance of Payment (as % of service exports) of New Caledonia in 2006 to that in 2009?
Give a very brief answer. 1.36. What is the ratio of the Balance of Payment (as % of service exports) of Samoa in 2006 to that in 2009?
Your answer should be very brief. 1.16. What is the ratio of the Balance of Payment (as % of service exports) of Sudan in 2006 to that in 2009?
Provide a short and direct response. 0.42. What is the ratio of the Balance of Payment (as % of service exports) in Macedonia in 2006 to that in 2010?
Your response must be concise. 0.8. What is the ratio of the Balance of Payment (as % of service exports) in New Caledonia in 2006 to that in 2010?
Make the answer very short. 0.73. What is the ratio of the Balance of Payment (as % of service exports) of Samoa in 2006 to that in 2010?
Your response must be concise. 1.47. What is the ratio of the Balance of Payment (as % of service exports) in Sudan in 2006 to that in 2010?
Provide a short and direct response. 0.1. What is the ratio of the Balance of Payment (as % of service exports) of Macedonia in 2006 to that in 2011?
Keep it short and to the point. 1.04. What is the ratio of the Balance of Payment (as % of service exports) in New Caledonia in 2006 to that in 2011?
Keep it short and to the point. 1.26. What is the ratio of the Balance of Payment (as % of service exports) in Samoa in 2006 to that in 2011?
Your answer should be very brief. 1.19. What is the ratio of the Balance of Payment (as % of service exports) in Sudan in 2006 to that in 2011?
Offer a very short reply. 0.48. What is the ratio of the Balance of Payment (as % of service exports) of Macedonia in 2006 to that in 2012?
Give a very brief answer. 1. What is the ratio of the Balance of Payment (as % of service exports) of New Caledonia in 2006 to that in 2012?
Ensure brevity in your answer.  1.67. What is the ratio of the Balance of Payment (as % of service exports) in Samoa in 2006 to that in 2012?
Keep it short and to the point. 1.71. What is the ratio of the Balance of Payment (as % of service exports) in Sudan in 2006 to that in 2012?
Give a very brief answer. 0.72. What is the ratio of the Balance of Payment (as % of service exports) in Macedonia in 2006 to that in 2013?
Provide a short and direct response. 0.97. What is the ratio of the Balance of Payment (as % of service exports) of New Caledonia in 2006 to that in 2013?
Make the answer very short. 1.31. What is the ratio of the Balance of Payment (as % of service exports) in Samoa in 2006 to that in 2013?
Offer a very short reply. 1.93. What is the ratio of the Balance of Payment (as % of service exports) in Sudan in 2006 to that in 2013?
Offer a terse response. 0.33. What is the ratio of the Balance of Payment (as % of service exports) in Macedonia in 2007 to that in 2008?
Provide a short and direct response. 0.92. What is the ratio of the Balance of Payment (as % of service exports) of New Caledonia in 2007 to that in 2008?
Provide a short and direct response. 0.77. What is the ratio of the Balance of Payment (as % of service exports) of Samoa in 2007 to that in 2008?
Provide a succinct answer. 1.13. What is the ratio of the Balance of Payment (as % of service exports) in Sudan in 2007 to that in 2008?
Offer a very short reply. 0.86. What is the ratio of the Balance of Payment (as % of service exports) in Macedonia in 2007 to that in 2009?
Offer a terse response. 0.9. What is the ratio of the Balance of Payment (as % of service exports) of New Caledonia in 2007 to that in 2009?
Offer a very short reply. 0.69. What is the ratio of the Balance of Payment (as % of service exports) of Samoa in 2007 to that in 2009?
Offer a terse response. 0.81. What is the ratio of the Balance of Payment (as % of service exports) of Sudan in 2007 to that in 2009?
Your response must be concise. 0.87. What is the ratio of the Balance of Payment (as % of service exports) of Macedonia in 2007 to that in 2010?
Your answer should be compact. 0.77. What is the ratio of the Balance of Payment (as % of service exports) of New Caledonia in 2007 to that in 2010?
Your response must be concise. 0.37. What is the ratio of the Balance of Payment (as % of service exports) in Samoa in 2007 to that in 2010?
Your answer should be very brief. 1.02. What is the ratio of the Balance of Payment (as % of service exports) of Sudan in 2007 to that in 2010?
Offer a terse response. 0.2. What is the ratio of the Balance of Payment (as % of service exports) of Macedonia in 2007 to that in 2011?
Your response must be concise. 0.99. What is the ratio of the Balance of Payment (as % of service exports) of New Caledonia in 2007 to that in 2011?
Your response must be concise. 0.64. What is the ratio of the Balance of Payment (as % of service exports) in Samoa in 2007 to that in 2011?
Provide a short and direct response. 0.83. What is the ratio of the Balance of Payment (as % of service exports) of Macedonia in 2007 to that in 2012?
Make the answer very short. 0.96. What is the ratio of the Balance of Payment (as % of service exports) of New Caledonia in 2007 to that in 2012?
Offer a terse response. 0.85. What is the ratio of the Balance of Payment (as % of service exports) in Samoa in 2007 to that in 2012?
Give a very brief answer. 1.19. What is the ratio of the Balance of Payment (as % of service exports) of Sudan in 2007 to that in 2012?
Ensure brevity in your answer.  1.5. What is the ratio of the Balance of Payment (as % of service exports) in Macedonia in 2007 to that in 2013?
Offer a terse response. 0.93. What is the ratio of the Balance of Payment (as % of service exports) in New Caledonia in 2007 to that in 2013?
Your answer should be very brief. 0.67. What is the ratio of the Balance of Payment (as % of service exports) of Samoa in 2007 to that in 2013?
Your answer should be very brief. 1.35. What is the ratio of the Balance of Payment (as % of service exports) in Sudan in 2007 to that in 2013?
Offer a terse response. 0.69. What is the ratio of the Balance of Payment (as % of service exports) of Macedonia in 2008 to that in 2009?
Provide a short and direct response. 0.99. What is the ratio of the Balance of Payment (as % of service exports) in New Caledonia in 2008 to that in 2009?
Your answer should be compact. 0.9. What is the ratio of the Balance of Payment (as % of service exports) in Samoa in 2008 to that in 2009?
Ensure brevity in your answer.  0.72. What is the ratio of the Balance of Payment (as % of service exports) in Sudan in 2008 to that in 2009?
Your answer should be compact. 1.02. What is the ratio of the Balance of Payment (as % of service exports) of Macedonia in 2008 to that in 2010?
Offer a terse response. 0.84. What is the ratio of the Balance of Payment (as % of service exports) in New Caledonia in 2008 to that in 2010?
Offer a very short reply. 0.48. What is the ratio of the Balance of Payment (as % of service exports) in Samoa in 2008 to that in 2010?
Give a very brief answer. 0.91. What is the ratio of the Balance of Payment (as % of service exports) of Sudan in 2008 to that in 2010?
Make the answer very short. 0.24. What is the ratio of the Balance of Payment (as % of service exports) in Macedonia in 2008 to that in 2011?
Ensure brevity in your answer.  1.08. What is the ratio of the Balance of Payment (as % of service exports) in New Caledonia in 2008 to that in 2011?
Your answer should be compact. 0.84. What is the ratio of the Balance of Payment (as % of service exports) in Samoa in 2008 to that in 2011?
Provide a short and direct response. 0.73. What is the ratio of the Balance of Payment (as % of service exports) of Sudan in 2008 to that in 2011?
Your answer should be very brief. 1.17. What is the ratio of the Balance of Payment (as % of service exports) in Macedonia in 2008 to that in 2012?
Make the answer very short. 1.04. What is the ratio of the Balance of Payment (as % of service exports) in New Caledonia in 2008 to that in 2012?
Your answer should be very brief. 1.11. What is the ratio of the Balance of Payment (as % of service exports) in Samoa in 2008 to that in 2012?
Offer a terse response. 1.05. What is the ratio of the Balance of Payment (as % of service exports) in Sudan in 2008 to that in 2012?
Provide a short and direct response. 1.76. What is the ratio of the Balance of Payment (as % of service exports) of Macedonia in 2008 to that in 2013?
Give a very brief answer. 1.01. What is the ratio of the Balance of Payment (as % of service exports) in New Caledonia in 2008 to that in 2013?
Ensure brevity in your answer.  0.87. What is the ratio of the Balance of Payment (as % of service exports) in Samoa in 2008 to that in 2013?
Your response must be concise. 1.19. What is the ratio of the Balance of Payment (as % of service exports) of Sudan in 2008 to that in 2013?
Give a very brief answer. 0.81. What is the ratio of the Balance of Payment (as % of service exports) in Macedonia in 2009 to that in 2010?
Give a very brief answer. 0.85. What is the ratio of the Balance of Payment (as % of service exports) in New Caledonia in 2009 to that in 2010?
Provide a succinct answer. 0.54. What is the ratio of the Balance of Payment (as % of service exports) of Samoa in 2009 to that in 2010?
Your answer should be very brief. 1.27. What is the ratio of the Balance of Payment (as % of service exports) of Sudan in 2009 to that in 2010?
Ensure brevity in your answer.  0.23. What is the ratio of the Balance of Payment (as % of service exports) in Macedonia in 2009 to that in 2011?
Ensure brevity in your answer.  1.1. What is the ratio of the Balance of Payment (as % of service exports) in New Caledonia in 2009 to that in 2011?
Your response must be concise. 0.93. What is the ratio of the Balance of Payment (as % of service exports) of Samoa in 2009 to that in 2011?
Your answer should be very brief. 1.03. What is the ratio of the Balance of Payment (as % of service exports) of Sudan in 2009 to that in 2011?
Your answer should be compact. 1.14. What is the ratio of the Balance of Payment (as % of service exports) in Macedonia in 2009 to that in 2012?
Make the answer very short. 1.06. What is the ratio of the Balance of Payment (as % of service exports) in New Caledonia in 2009 to that in 2012?
Give a very brief answer. 1.23. What is the ratio of the Balance of Payment (as % of service exports) in Samoa in 2009 to that in 2012?
Your answer should be compact. 1.47. What is the ratio of the Balance of Payment (as % of service exports) of Sudan in 2009 to that in 2012?
Offer a terse response. 1.72. What is the ratio of the Balance of Payment (as % of service exports) in Macedonia in 2009 to that in 2013?
Offer a terse response. 1.03. What is the ratio of the Balance of Payment (as % of service exports) of New Caledonia in 2009 to that in 2013?
Offer a very short reply. 0.96. What is the ratio of the Balance of Payment (as % of service exports) in Samoa in 2009 to that in 2013?
Give a very brief answer. 1.67. What is the ratio of the Balance of Payment (as % of service exports) in Sudan in 2009 to that in 2013?
Ensure brevity in your answer.  0.8. What is the ratio of the Balance of Payment (as % of service exports) in Macedonia in 2010 to that in 2011?
Provide a succinct answer. 1.29. What is the ratio of the Balance of Payment (as % of service exports) in New Caledonia in 2010 to that in 2011?
Ensure brevity in your answer.  1.73. What is the ratio of the Balance of Payment (as % of service exports) of Samoa in 2010 to that in 2011?
Provide a short and direct response. 0.81. What is the ratio of the Balance of Payment (as % of service exports) in Sudan in 2010 to that in 2011?
Your answer should be very brief. 4.89. What is the ratio of the Balance of Payment (as % of service exports) in Macedonia in 2010 to that in 2012?
Offer a very short reply. 1.25. What is the ratio of the Balance of Payment (as % of service exports) of New Caledonia in 2010 to that in 2012?
Make the answer very short. 2.29. What is the ratio of the Balance of Payment (as % of service exports) in Samoa in 2010 to that in 2012?
Ensure brevity in your answer.  1.16. What is the ratio of the Balance of Payment (as % of service exports) in Sudan in 2010 to that in 2012?
Keep it short and to the point. 7.38. What is the ratio of the Balance of Payment (as % of service exports) of Macedonia in 2010 to that in 2013?
Keep it short and to the point. 1.21. What is the ratio of the Balance of Payment (as % of service exports) of New Caledonia in 2010 to that in 2013?
Keep it short and to the point. 1.8. What is the ratio of the Balance of Payment (as % of service exports) of Samoa in 2010 to that in 2013?
Offer a very short reply. 1.32. What is the ratio of the Balance of Payment (as % of service exports) of Sudan in 2010 to that in 2013?
Your response must be concise. 3.41. What is the ratio of the Balance of Payment (as % of service exports) of Macedonia in 2011 to that in 2012?
Make the answer very short. 0.96. What is the ratio of the Balance of Payment (as % of service exports) of New Caledonia in 2011 to that in 2012?
Make the answer very short. 1.32. What is the ratio of the Balance of Payment (as % of service exports) in Samoa in 2011 to that in 2012?
Your answer should be compact. 1.43. What is the ratio of the Balance of Payment (as % of service exports) of Sudan in 2011 to that in 2012?
Your response must be concise. 1.51. What is the ratio of the Balance of Payment (as % of service exports) of Macedonia in 2011 to that in 2013?
Make the answer very short. 0.94. What is the ratio of the Balance of Payment (as % of service exports) in New Caledonia in 2011 to that in 2013?
Make the answer very short. 1.04. What is the ratio of the Balance of Payment (as % of service exports) in Samoa in 2011 to that in 2013?
Your answer should be compact. 1.62. What is the ratio of the Balance of Payment (as % of service exports) of Sudan in 2011 to that in 2013?
Provide a short and direct response. 0.7. What is the ratio of the Balance of Payment (as % of service exports) of Macedonia in 2012 to that in 2013?
Provide a short and direct response. 0.97. What is the ratio of the Balance of Payment (as % of service exports) in New Caledonia in 2012 to that in 2013?
Your response must be concise. 0.78. What is the ratio of the Balance of Payment (as % of service exports) in Samoa in 2012 to that in 2013?
Your answer should be compact. 1.13. What is the ratio of the Balance of Payment (as % of service exports) of Sudan in 2012 to that in 2013?
Provide a short and direct response. 0.46. What is the difference between the highest and the second highest Balance of Payment (as % of service exports) of Macedonia?
Your answer should be compact. 4.53. What is the difference between the highest and the second highest Balance of Payment (as % of service exports) in New Caledonia?
Provide a short and direct response. 5.17. What is the difference between the highest and the second highest Balance of Payment (as % of service exports) of Samoa?
Provide a short and direct response. 1.85. What is the difference between the highest and the second highest Balance of Payment (as % of service exports) in Sudan?
Provide a succinct answer. 21.87. What is the difference between the highest and the lowest Balance of Payment (as % of service exports) of Macedonia?
Ensure brevity in your answer.  6.93. What is the difference between the highest and the lowest Balance of Payment (as % of service exports) in New Caledonia?
Your answer should be compact. 12.07. What is the difference between the highest and the lowest Balance of Payment (as % of service exports) of Samoa?
Keep it short and to the point. 6.47. What is the difference between the highest and the lowest Balance of Payment (as % of service exports) of Sudan?
Your answer should be compact. 27.94. 